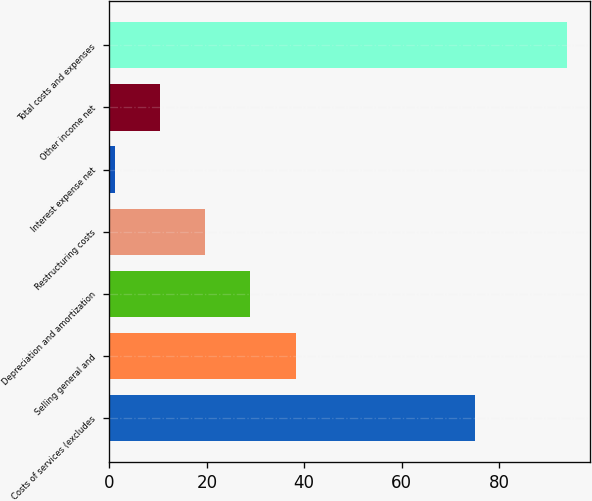<chart> <loc_0><loc_0><loc_500><loc_500><bar_chart><fcel>Costs of services (excludes<fcel>Selling general and<fcel>Depreciation and amortization<fcel>Restructuring costs<fcel>Interest expense net<fcel>Other income net<fcel>Total costs and expenses<nl><fcel>75<fcel>38.26<fcel>28.97<fcel>19.68<fcel>1.1<fcel>10.39<fcel>94<nl></chart> 